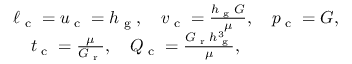<formula> <loc_0><loc_0><loc_500><loc_500>\begin{array} { r l r } & { \ell _ { c } = u _ { c } = h _ { g } , \quad v _ { c } = \frac { h _ { g } G } { \mu } , \quad p _ { c } = G , } & \\ & { \quad t _ { c } = \frac { \mu } { G _ { r } } , \quad Q _ { c } = \frac { G _ { r } h _ { g } ^ { 3 } } { \mu } , } \end{array}</formula> 